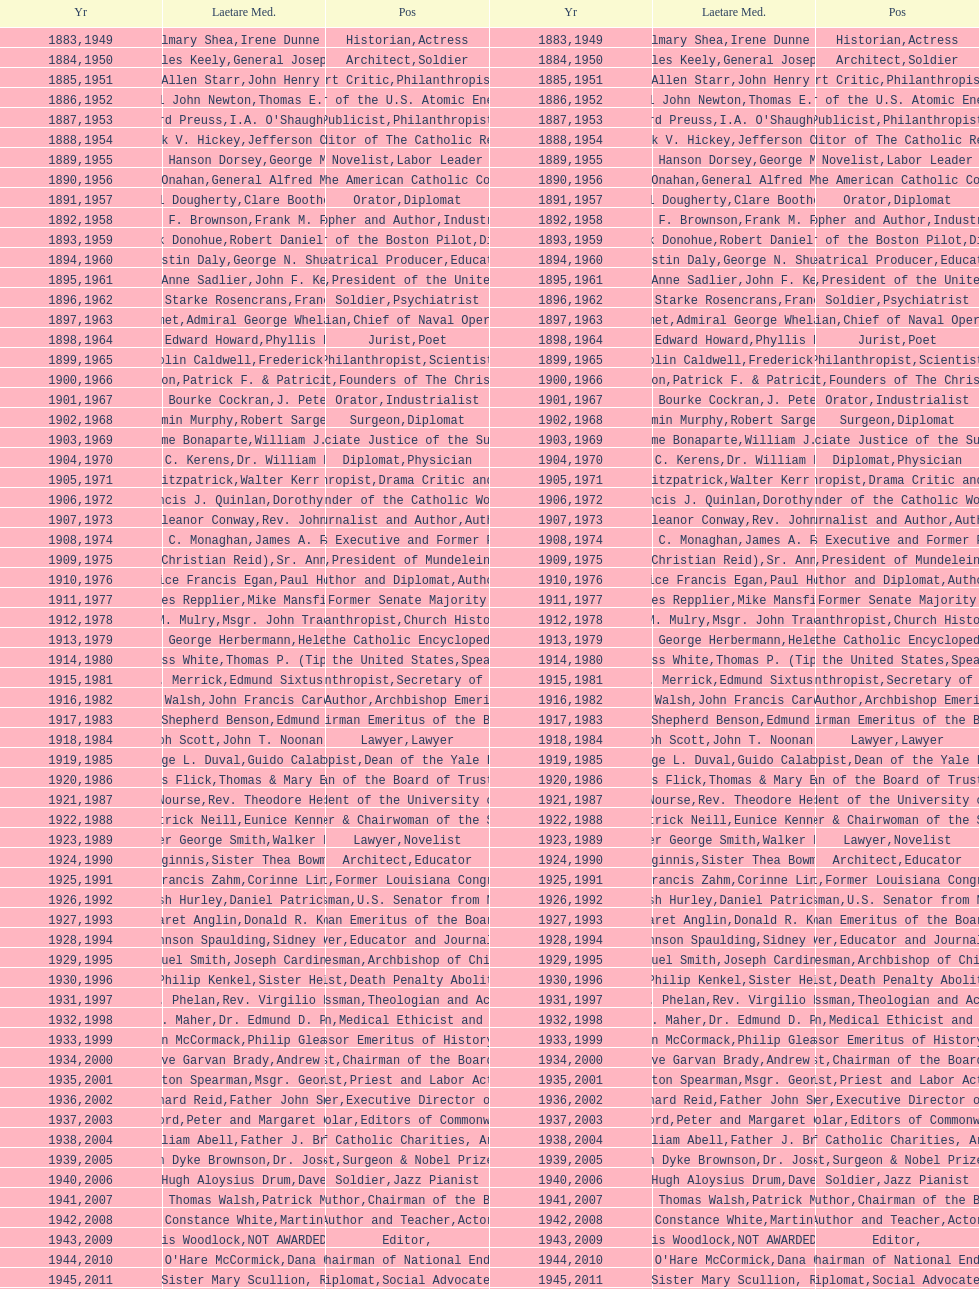Who has won this medal and the nobel prize as well? Dr. Joseph E. Murray. 